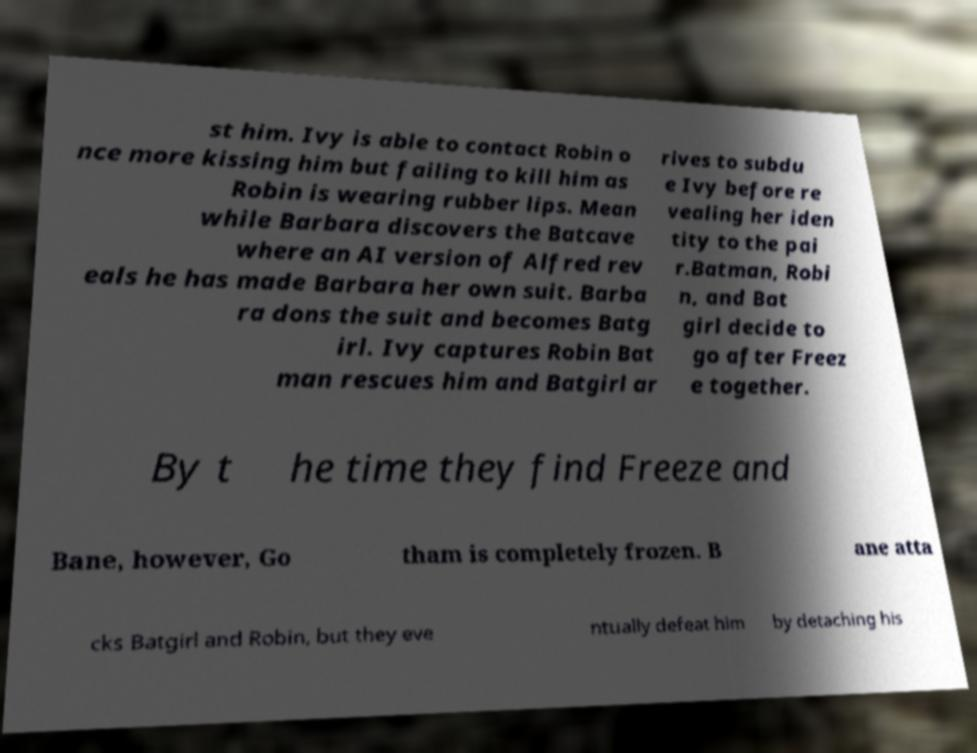Can you read and provide the text displayed in the image?This photo seems to have some interesting text. Can you extract and type it out for me? st him. Ivy is able to contact Robin o nce more kissing him but failing to kill him as Robin is wearing rubber lips. Mean while Barbara discovers the Batcave where an AI version of Alfred rev eals he has made Barbara her own suit. Barba ra dons the suit and becomes Batg irl. Ivy captures Robin Bat man rescues him and Batgirl ar rives to subdu e Ivy before re vealing her iden tity to the pai r.Batman, Robi n, and Bat girl decide to go after Freez e together. By t he time they find Freeze and Bane, however, Go tham is completely frozen. B ane atta cks Batgirl and Robin, but they eve ntually defeat him by detaching his 